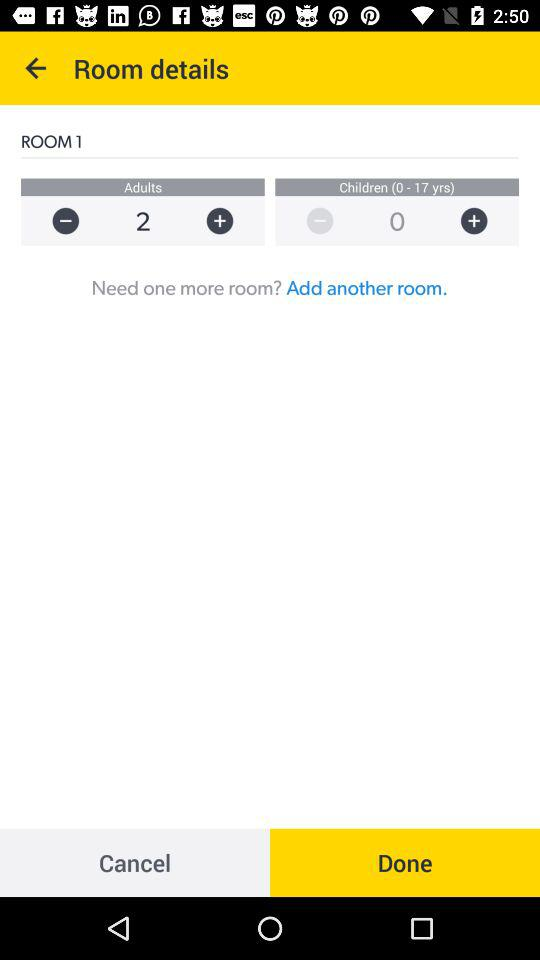How many rooms are there?
Answer the question using a single word or phrase. 1 